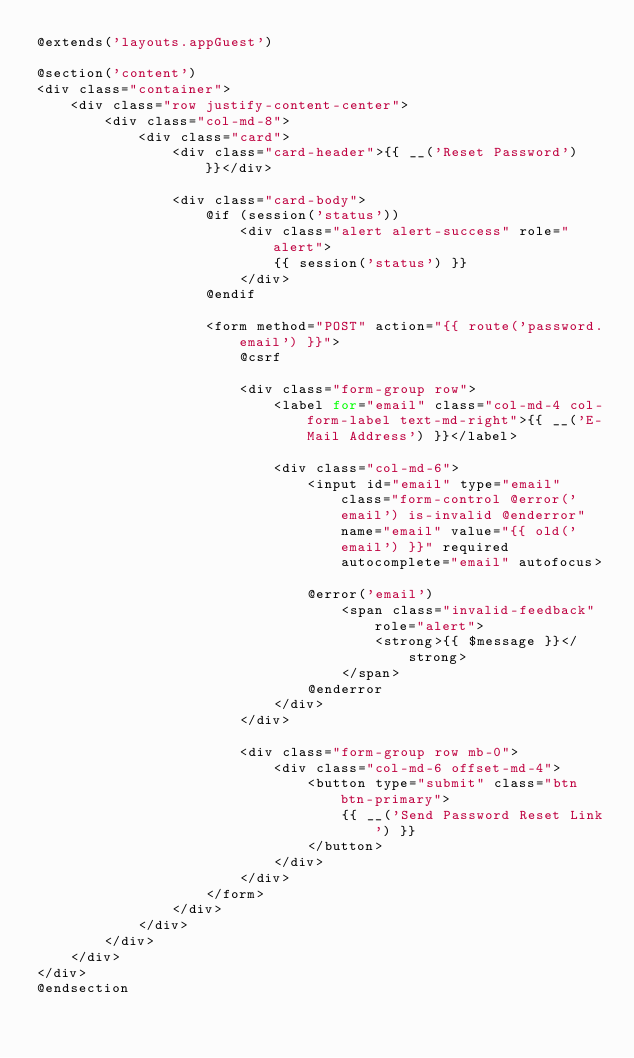<code> <loc_0><loc_0><loc_500><loc_500><_PHP_>@extends('layouts.appGuest')

@section('content')
<div class="container">
    <div class="row justify-content-center">
        <div class="col-md-8">
            <div class="card">
                <div class="card-header">{{ __('Reset Password') }}</div>

                <div class="card-body">
                    @if (session('status'))
                        <div class="alert alert-success" role="alert">
                            {{ session('status') }}
                        </div>
                    @endif

                    <form method="POST" action="{{ route('password.email') }}">
                        @csrf

                        <div class="form-group row">
                            <label for="email" class="col-md-4 col-form-label text-md-right">{{ __('E-Mail Address') }}</label>

                            <div class="col-md-6">
                                <input id="email" type="email" class="form-control @error('email') is-invalid @enderror" name="email" value="{{ old('email') }}" required autocomplete="email" autofocus>

                                @error('email')
                                    <span class="invalid-feedback" role="alert">
                                        <strong>{{ $message }}</strong>
                                    </span>
                                @enderror
                            </div>
                        </div>

                        <div class="form-group row mb-0">
                            <div class="col-md-6 offset-md-4">
                                <button type="submit" class="btn btn-primary">
                                    {{ __('Send Password Reset Link') }}
                                </button>
                            </div>
                        </div>
                    </form>
                </div>
            </div>
        </div>
    </div>
</div>
@endsection
</code> 